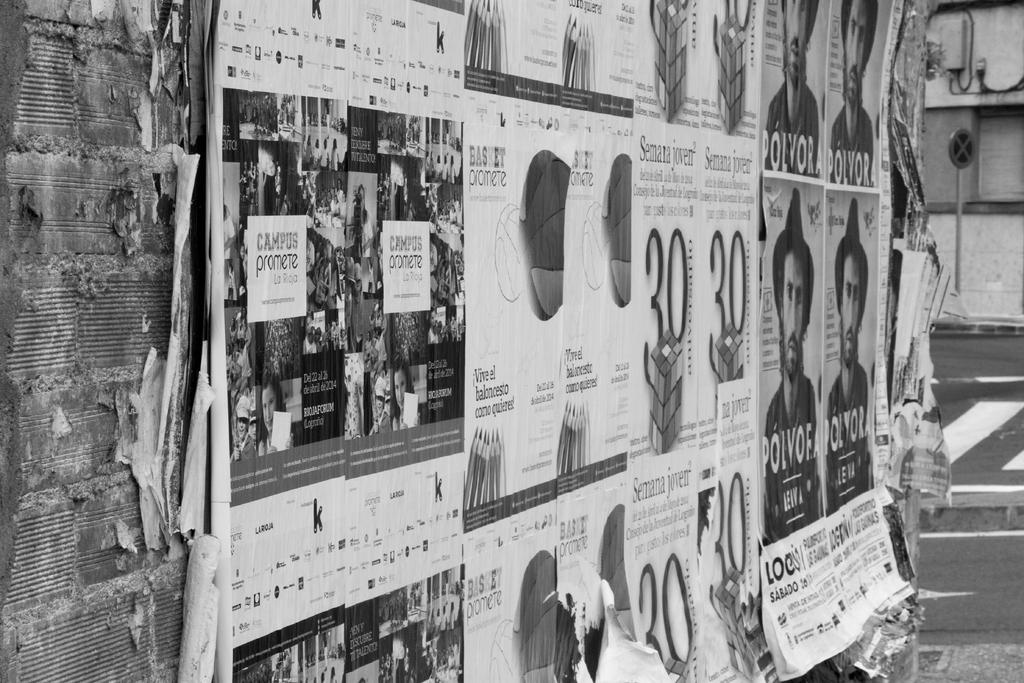What is the color scheme of the image? The image is black and white. What can be seen on the wall in the image? There are posts on the wall in the image. What is located in the background of the image? There is a pole in the background of the image. What is visible at the bottom of the image? There is a road visible at the bottom of the image. Can you see a goose combing its feathers in the image? There is no goose or comb present in the image. What thought is being expressed by the pole in the image? The pole is an inanimate object and cannot express thoughts. 